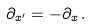Convert formula to latex. <formula><loc_0><loc_0><loc_500><loc_500>\partial _ { x ^ { \prime } } = - \partial _ { x } \, .</formula> 